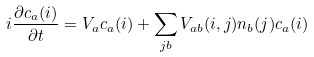<formula> <loc_0><loc_0><loc_500><loc_500>i \frac { \partial c _ { a } ( i ) } { \partial t } = V _ { a } c _ { a } ( i ) + \sum _ { j b } V _ { a b } ( i , j ) n _ { b } ( j ) c _ { a } ( i )</formula> 